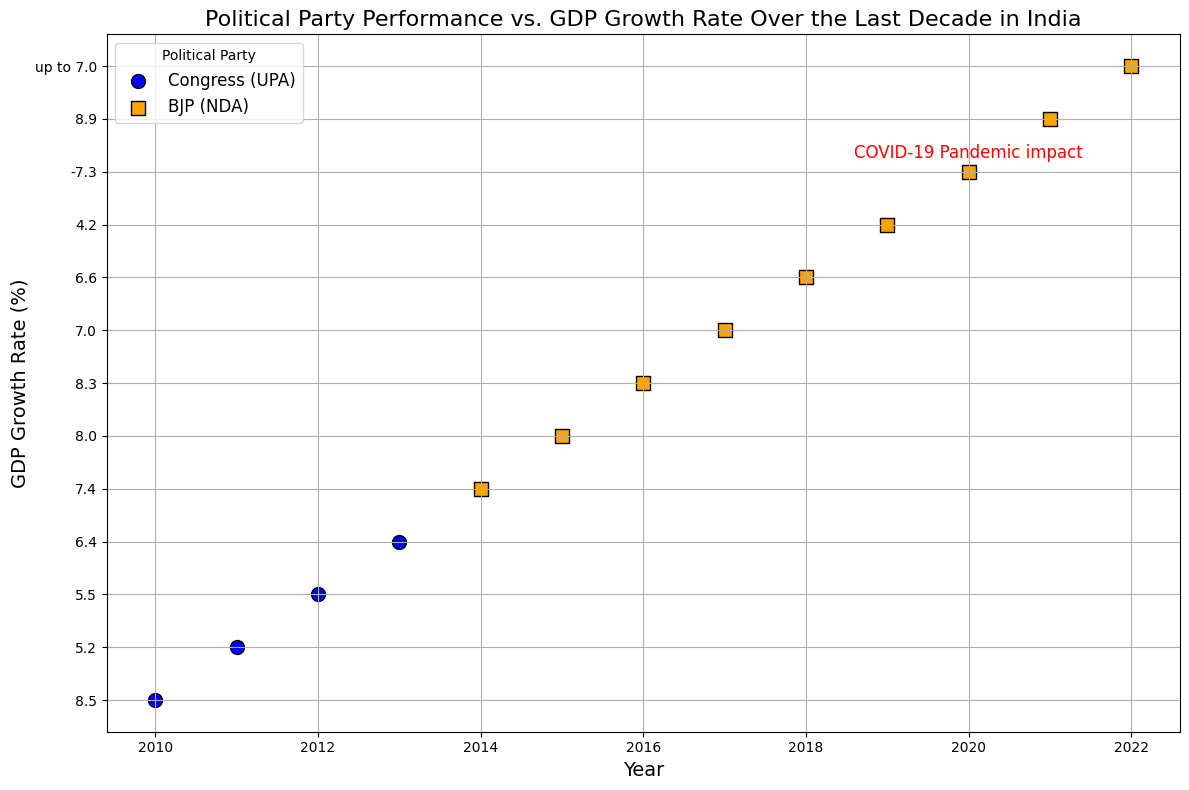Which political party had the highest GDP growth rate during their tenure? For the highest GDP growth rate, look for the maximum value in the y-axis. The highest value is 8.9% in 2021 which was under BJP (NDA).
Answer: BJP (NDA) What was the GDP growth rate in 2020, and was there any annotation for that year? Locate the point for the year 2020 on the x-axis and check its corresponding y-axis value. The point shows a GDP growth rate of -7.3% with the annotation "COVID-19 Pandemic impact".
Answer: -7.3%, COVID-19 Pandemic impact Compare the GDP growth rate in 2014 with 2019. Which year had a better growth rate, and what were the respective rates? Find the points for years 2014 and 2019 on the x-axis and compare their y-axis values. For 2014, the GDP growth rate was 7.4%, and for 2019, it was 4.2%. Hence, 2014 had a better growth rate.
Answer: 2014 (7.4%), 2019 (4.2%), 2014 had a better growth rate Calculate the average GDP growth rate during the BJP (NDA) tenure. Average of the GDP growth rates in BJP (NDA) tenure from 2014 to 2022. Add the rates: 7.4 + 8.0 + 8.3 + 7.0 + 6.6 + 4.2 + (-7.3) + 8.9 + 7.0 = 50.1. Divide by 9 (number of years) which is around 5.57%.
Answer: ~5.57% What is the difference in GDP growth rates between 2010 and 2011? Locate the points for years 2010 and 2011 and find the difference in their y-axis values. For 2010 the rate was 8.5%, and for 2011 it was 5.2%. The difference is 8.5% - 5.2% = 3.3%.
Answer: 3.3% Which year had the lowest GDP growth rate and what was it? Identify the lowest point on the y-axis. The year 2020 had the lowest GDP growth rate at -7.3%.
Answer: 2020, -7.3% 